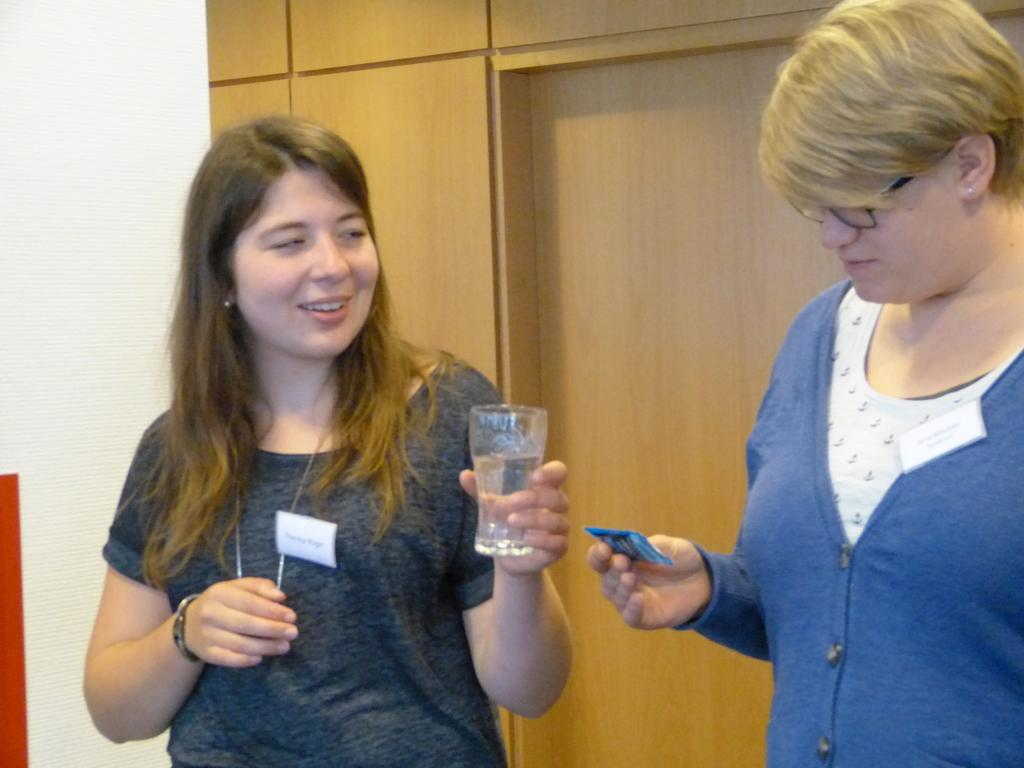How many people are in the image? There are two ladies standing in the image. What is the lady on the left holding? The lady on the left is holding a glass. What can be seen in the background of the image? There is a wall in the background of the image. What type of lace can be seen on the cow in the image? There is no cow present in the image, and therefore no lace can be observed. 